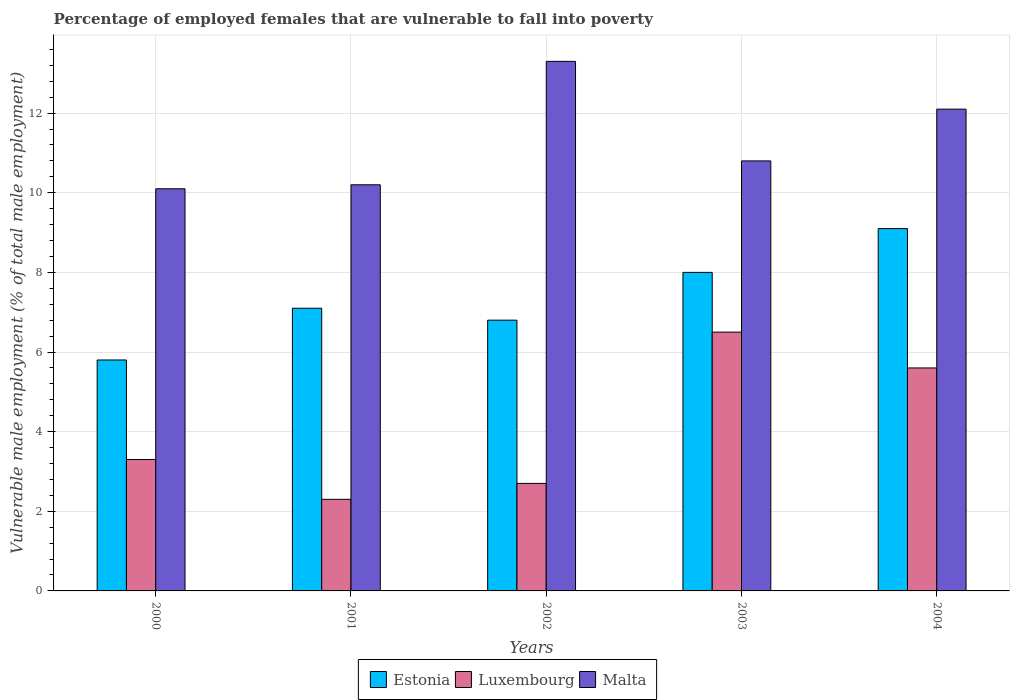How many different coloured bars are there?
Give a very brief answer. 3. How many groups of bars are there?
Provide a short and direct response. 5. Are the number of bars per tick equal to the number of legend labels?
Your answer should be compact. Yes. What is the percentage of employed females who are vulnerable to fall into poverty in Malta in 2003?
Your answer should be compact. 10.8. Across all years, what is the minimum percentage of employed females who are vulnerable to fall into poverty in Estonia?
Provide a short and direct response. 5.8. In which year was the percentage of employed females who are vulnerable to fall into poverty in Malta minimum?
Ensure brevity in your answer.  2000. What is the total percentage of employed females who are vulnerable to fall into poverty in Luxembourg in the graph?
Make the answer very short. 20.4. What is the difference between the percentage of employed females who are vulnerable to fall into poverty in Luxembourg in 2002 and that in 2004?
Your response must be concise. -2.9. What is the difference between the percentage of employed females who are vulnerable to fall into poverty in Estonia in 2003 and the percentage of employed females who are vulnerable to fall into poverty in Luxembourg in 2004?
Offer a terse response. 2.4. What is the average percentage of employed females who are vulnerable to fall into poverty in Luxembourg per year?
Provide a succinct answer. 4.08. In the year 2000, what is the difference between the percentage of employed females who are vulnerable to fall into poverty in Estonia and percentage of employed females who are vulnerable to fall into poverty in Malta?
Offer a very short reply. -4.3. What is the ratio of the percentage of employed females who are vulnerable to fall into poverty in Luxembourg in 2002 to that in 2003?
Offer a terse response. 0.42. Is the percentage of employed females who are vulnerable to fall into poverty in Malta in 2002 less than that in 2003?
Provide a succinct answer. No. Is the difference between the percentage of employed females who are vulnerable to fall into poverty in Estonia in 2000 and 2001 greater than the difference between the percentage of employed females who are vulnerable to fall into poverty in Malta in 2000 and 2001?
Provide a short and direct response. No. What is the difference between the highest and the second highest percentage of employed females who are vulnerable to fall into poverty in Malta?
Give a very brief answer. 1.2. What is the difference between the highest and the lowest percentage of employed females who are vulnerable to fall into poverty in Malta?
Your response must be concise. 3.2. In how many years, is the percentage of employed females who are vulnerable to fall into poverty in Luxembourg greater than the average percentage of employed females who are vulnerable to fall into poverty in Luxembourg taken over all years?
Offer a very short reply. 2. Is the sum of the percentage of employed females who are vulnerable to fall into poverty in Estonia in 2002 and 2003 greater than the maximum percentage of employed females who are vulnerable to fall into poverty in Luxembourg across all years?
Your answer should be compact. Yes. What does the 2nd bar from the left in 2000 represents?
Make the answer very short. Luxembourg. What does the 3rd bar from the right in 2004 represents?
Make the answer very short. Estonia. How many bars are there?
Offer a very short reply. 15. Are the values on the major ticks of Y-axis written in scientific E-notation?
Provide a succinct answer. No. Does the graph contain any zero values?
Make the answer very short. No. Where does the legend appear in the graph?
Provide a succinct answer. Bottom center. How many legend labels are there?
Ensure brevity in your answer.  3. How are the legend labels stacked?
Offer a terse response. Horizontal. What is the title of the graph?
Offer a very short reply. Percentage of employed females that are vulnerable to fall into poverty. What is the label or title of the X-axis?
Your response must be concise. Years. What is the label or title of the Y-axis?
Your answer should be compact. Vulnerable male employment (% of total male employment). What is the Vulnerable male employment (% of total male employment) in Estonia in 2000?
Ensure brevity in your answer.  5.8. What is the Vulnerable male employment (% of total male employment) of Luxembourg in 2000?
Give a very brief answer. 3.3. What is the Vulnerable male employment (% of total male employment) in Malta in 2000?
Your answer should be compact. 10.1. What is the Vulnerable male employment (% of total male employment) of Estonia in 2001?
Make the answer very short. 7.1. What is the Vulnerable male employment (% of total male employment) of Luxembourg in 2001?
Give a very brief answer. 2.3. What is the Vulnerable male employment (% of total male employment) of Malta in 2001?
Provide a succinct answer. 10.2. What is the Vulnerable male employment (% of total male employment) in Estonia in 2002?
Your answer should be very brief. 6.8. What is the Vulnerable male employment (% of total male employment) in Luxembourg in 2002?
Make the answer very short. 2.7. What is the Vulnerable male employment (% of total male employment) of Malta in 2002?
Keep it short and to the point. 13.3. What is the Vulnerable male employment (% of total male employment) in Luxembourg in 2003?
Make the answer very short. 6.5. What is the Vulnerable male employment (% of total male employment) of Malta in 2003?
Your answer should be very brief. 10.8. What is the Vulnerable male employment (% of total male employment) in Estonia in 2004?
Your answer should be compact. 9.1. What is the Vulnerable male employment (% of total male employment) in Luxembourg in 2004?
Ensure brevity in your answer.  5.6. What is the Vulnerable male employment (% of total male employment) of Malta in 2004?
Ensure brevity in your answer.  12.1. Across all years, what is the maximum Vulnerable male employment (% of total male employment) of Estonia?
Give a very brief answer. 9.1. Across all years, what is the maximum Vulnerable male employment (% of total male employment) in Malta?
Make the answer very short. 13.3. Across all years, what is the minimum Vulnerable male employment (% of total male employment) in Estonia?
Ensure brevity in your answer.  5.8. Across all years, what is the minimum Vulnerable male employment (% of total male employment) of Luxembourg?
Provide a succinct answer. 2.3. Across all years, what is the minimum Vulnerable male employment (% of total male employment) of Malta?
Offer a terse response. 10.1. What is the total Vulnerable male employment (% of total male employment) in Estonia in the graph?
Provide a short and direct response. 36.8. What is the total Vulnerable male employment (% of total male employment) in Luxembourg in the graph?
Offer a terse response. 20.4. What is the total Vulnerable male employment (% of total male employment) in Malta in the graph?
Offer a terse response. 56.5. What is the difference between the Vulnerable male employment (% of total male employment) in Estonia in 2000 and that in 2001?
Keep it short and to the point. -1.3. What is the difference between the Vulnerable male employment (% of total male employment) in Malta in 2000 and that in 2001?
Offer a terse response. -0.1. What is the difference between the Vulnerable male employment (% of total male employment) in Estonia in 2000 and that in 2002?
Give a very brief answer. -1. What is the difference between the Vulnerable male employment (% of total male employment) of Malta in 2000 and that in 2002?
Offer a terse response. -3.2. What is the difference between the Vulnerable male employment (% of total male employment) in Estonia in 2000 and that in 2004?
Your answer should be compact. -3.3. What is the difference between the Vulnerable male employment (% of total male employment) of Luxembourg in 2000 and that in 2004?
Your answer should be very brief. -2.3. What is the difference between the Vulnerable male employment (% of total male employment) in Estonia in 2001 and that in 2002?
Keep it short and to the point. 0.3. What is the difference between the Vulnerable male employment (% of total male employment) in Luxembourg in 2001 and that in 2002?
Your answer should be compact. -0.4. What is the difference between the Vulnerable male employment (% of total male employment) in Malta in 2001 and that in 2002?
Your response must be concise. -3.1. What is the difference between the Vulnerable male employment (% of total male employment) of Estonia in 2001 and that in 2003?
Give a very brief answer. -0.9. What is the difference between the Vulnerable male employment (% of total male employment) of Malta in 2001 and that in 2003?
Keep it short and to the point. -0.6. What is the difference between the Vulnerable male employment (% of total male employment) in Malta in 2001 and that in 2004?
Ensure brevity in your answer.  -1.9. What is the difference between the Vulnerable male employment (% of total male employment) of Estonia in 2002 and that in 2003?
Give a very brief answer. -1.2. What is the difference between the Vulnerable male employment (% of total male employment) in Luxembourg in 2002 and that in 2003?
Keep it short and to the point. -3.8. What is the difference between the Vulnerable male employment (% of total male employment) in Malta in 2002 and that in 2003?
Keep it short and to the point. 2.5. What is the difference between the Vulnerable male employment (% of total male employment) of Luxembourg in 2002 and that in 2004?
Your answer should be very brief. -2.9. What is the difference between the Vulnerable male employment (% of total male employment) in Estonia in 2003 and that in 2004?
Your answer should be very brief. -1.1. What is the difference between the Vulnerable male employment (% of total male employment) in Estonia in 2000 and the Vulnerable male employment (% of total male employment) in Luxembourg in 2001?
Your response must be concise. 3.5. What is the difference between the Vulnerable male employment (% of total male employment) in Estonia in 2000 and the Vulnerable male employment (% of total male employment) in Malta in 2001?
Make the answer very short. -4.4. What is the difference between the Vulnerable male employment (% of total male employment) of Estonia in 2000 and the Vulnerable male employment (% of total male employment) of Luxembourg in 2002?
Your answer should be compact. 3.1. What is the difference between the Vulnerable male employment (% of total male employment) in Estonia in 2000 and the Vulnerable male employment (% of total male employment) in Malta in 2002?
Provide a succinct answer. -7.5. What is the difference between the Vulnerable male employment (% of total male employment) of Estonia in 2000 and the Vulnerable male employment (% of total male employment) of Malta in 2003?
Make the answer very short. -5. What is the difference between the Vulnerable male employment (% of total male employment) in Luxembourg in 2000 and the Vulnerable male employment (% of total male employment) in Malta in 2003?
Provide a succinct answer. -7.5. What is the difference between the Vulnerable male employment (% of total male employment) of Estonia in 2000 and the Vulnerable male employment (% of total male employment) of Luxembourg in 2004?
Your answer should be very brief. 0.2. What is the difference between the Vulnerable male employment (% of total male employment) in Estonia in 2000 and the Vulnerable male employment (% of total male employment) in Malta in 2004?
Make the answer very short. -6.3. What is the difference between the Vulnerable male employment (% of total male employment) of Luxembourg in 2001 and the Vulnerable male employment (% of total male employment) of Malta in 2003?
Your answer should be very brief. -8.5. What is the difference between the Vulnerable male employment (% of total male employment) of Estonia in 2001 and the Vulnerable male employment (% of total male employment) of Luxembourg in 2004?
Give a very brief answer. 1.5. What is the difference between the Vulnerable male employment (% of total male employment) in Estonia in 2001 and the Vulnerable male employment (% of total male employment) in Malta in 2004?
Offer a terse response. -5. What is the difference between the Vulnerable male employment (% of total male employment) of Estonia in 2002 and the Vulnerable male employment (% of total male employment) of Luxembourg in 2003?
Offer a terse response. 0.3. What is the difference between the Vulnerable male employment (% of total male employment) of Luxembourg in 2002 and the Vulnerable male employment (% of total male employment) of Malta in 2003?
Provide a succinct answer. -8.1. What is the difference between the Vulnerable male employment (% of total male employment) of Estonia in 2002 and the Vulnerable male employment (% of total male employment) of Luxembourg in 2004?
Give a very brief answer. 1.2. What is the difference between the Vulnerable male employment (% of total male employment) in Luxembourg in 2002 and the Vulnerable male employment (% of total male employment) in Malta in 2004?
Your response must be concise. -9.4. What is the difference between the Vulnerable male employment (% of total male employment) of Luxembourg in 2003 and the Vulnerable male employment (% of total male employment) of Malta in 2004?
Make the answer very short. -5.6. What is the average Vulnerable male employment (% of total male employment) of Estonia per year?
Your answer should be very brief. 7.36. What is the average Vulnerable male employment (% of total male employment) in Luxembourg per year?
Your answer should be very brief. 4.08. In the year 2000, what is the difference between the Vulnerable male employment (% of total male employment) of Estonia and Vulnerable male employment (% of total male employment) of Luxembourg?
Ensure brevity in your answer.  2.5. In the year 2000, what is the difference between the Vulnerable male employment (% of total male employment) of Estonia and Vulnerable male employment (% of total male employment) of Malta?
Give a very brief answer. -4.3. In the year 2001, what is the difference between the Vulnerable male employment (% of total male employment) of Estonia and Vulnerable male employment (% of total male employment) of Luxembourg?
Offer a very short reply. 4.8. In the year 2001, what is the difference between the Vulnerable male employment (% of total male employment) in Estonia and Vulnerable male employment (% of total male employment) in Malta?
Your response must be concise. -3.1. In the year 2001, what is the difference between the Vulnerable male employment (% of total male employment) in Luxembourg and Vulnerable male employment (% of total male employment) in Malta?
Your answer should be compact. -7.9. In the year 2002, what is the difference between the Vulnerable male employment (% of total male employment) in Estonia and Vulnerable male employment (% of total male employment) in Malta?
Keep it short and to the point. -6.5. In the year 2002, what is the difference between the Vulnerable male employment (% of total male employment) of Luxembourg and Vulnerable male employment (% of total male employment) of Malta?
Ensure brevity in your answer.  -10.6. In the year 2003, what is the difference between the Vulnerable male employment (% of total male employment) of Estonia and Vulnerable male employment (% of total male employment) of Luxembourg?
Give a very brief answer. 1.5. In the year 2003, what is the difference between the Vulnerable male employment (% of total male employment) in Estonia and Vulnerable male employment (% of total male employment) in Malta?
Ensure brevity in your answer.  -2.8. In the year 2003, what is the difference between the Vulnerable male employment (% of total male employment) in Luxembourg and Vulnerable male employment (% of total male employment) in Malta?
Keep it short and to the point. -4.3. In the year 2004, what is the difference between the Vulnerable male employment (% of total male employment) in Estonia and Vulnerable male employment (% of total male employment) in Luxembourg?
Give a very brief answer. 3.5. What is the ratio of the Vulnerable male employment (% of total male employment) in Estonia in 2000 to that in 2001?
Give a very brief answer. 0.82. What is the ratio of the Vulnerable male employment (% of total male employment) of Luxembourg in 2000 to that in 2001?
Your answer should be very brief. 1.43. What is the ratio of the Vulnerable male employment (% of total male employment) of Malta in 2000 to that in 2001?
Your answer should be very brief. 0.99. What is the ratio of the Vulnerable male employment (% of total male employment) of Estonia in 2000 to that in 2002?
Offer a terse response. 0.85. What is the ratio of the Vulnerable male employment (% of total male employment) of Luxembourg in 2000 to that in 2002?
Your response must be concise. 1.22. What is the ratio of the Vulnerable male employment (% of total male employment) of Malta in 2000 to that in 2002?
Make the answer very short. 0.76. What is the ratio of the Vulnerable male employment (% of total male employment) in Estonia in 2000 to that in 2003?
Make the answer very short. 0.72. What is the ratio of the Vulnerable male employment (% of total male employment) in Luxembourg in 2000 to that in 2003?
Keep it short and to the point. 0.51. What is the ratio of the Vulnerable male employment (% of total male employment) of Malta in 2000 to that in 2003?
Ensure brevity in your answer.  0.94. What is the ratio of the Vulnerable male employment (% of total male employment) in Estonia in 2000 to that in 2004?
Your answer should be very brief. 0.64. What is the ratio of the Vulnerable male employment (% of total male employment) in Luxembourg in 2000 to that in 2004?
Keep it short and to the point. 0.59. What is the ratio of the Vulnerable male employment (% of total male employment) in Malta in 2000 to that in 2004?
Give a very brief answer. 0.83. What is the ratio of the Vulnerable male employment (% of total male employment) of Estonia in 2001 to that in 2002?
Make the answer very short. 1.04. What is the ratio of the Vulnerable male employment (% of total male employment) in Luxembourg in 2001 to that in 2002?
Give a very brief answer. 0.85. What is the ratio of the Vulnerable male employment (% of total male employment) of Malta in 2001 to that in 2002?
Your answer should be compact. 0.77. What is the ratio of the Vulnerable male employment (% of total male employment) of Estonia in 2001 to that in 2003?
Keep it short and to the point. 0.89. What is the ratio of the Vulnerable male employment (% of total male employment) in Luxembourg in 2001 to that in 2003?
Make the answer very short. 0.35. What is the ratio of the Vulnerable male employment (% of total male employment) in Malta in 2001 to that in 2003?
Ensure brevity in your answer.  0.94. What is the ratio of the Vulnerable male employment (% of total male employment) of Estonia in 2001 to that in 2004?
Your response must be concise. 0.78. What is the ratio of the Vulnerable male employment (% of total male employment) in Luxembourg in 2001 to that in 2004?
Make the answer very short. 0.41. What is the ratio of the Vulnerable male employment (% of total male employment) of Malta in 2001 to that in 2004?
Offer a terse response. 0.84. What is the ratio of the Vulnerable male employment (% of total male employment) of Luxembourg in 2002 to that in 2003?
Give a very brief answer. 0.42. What is the ratio of the Vulnerable male employment (% of total male employment) of Malta in 2002 to that in 2003?
Offer a very short reply. 1.23. What is the ratio of the Vulnerable male employment (% of total male employment) in Estonia in 2002 to that in 2004?
Provide a succinct answer. 0.75. What is the ratio of the Vulnerable male employment (% of total male employment) in Luxembourg in 2002 to that in 2004?
Give a very brief answer. 0.48. What is the ratio of the Vulnerable male employment (% of total male employment) in Malta in 2002 to that in 2004?
Make the answer very short. 1.1. What is the ratio of the Vulnerable male employment (% of total male employment) of Estonia in 2003 to that in 2004?
Ensure brevity in your answer.  0.88. What is the ratio of the Vulnerable male employment (% of total male employment) of Luxembourg in 2003 to that in 2004?
Offer a terse response. 1.16. What is the ratio of the Vulnerable male employment (% of total male employment) in Malta in 2003 to that in 2004?
Offer a terse response. 0.89. What is the difference between the highest and the second highest Vulnerable male employment (% of total male employment) of Estonia?
Ensure brevity in your answer.  1.1. What is the difference between the highest and the lowest Vulnerable male employment (% of total male employment) in Estonia?
Give a very brief answer. 3.3. What is the difference between the highest and the lowest Vulnerable male employment (% of total male employment) in Malta?
Ensure brevity in your answer.  3.2. 